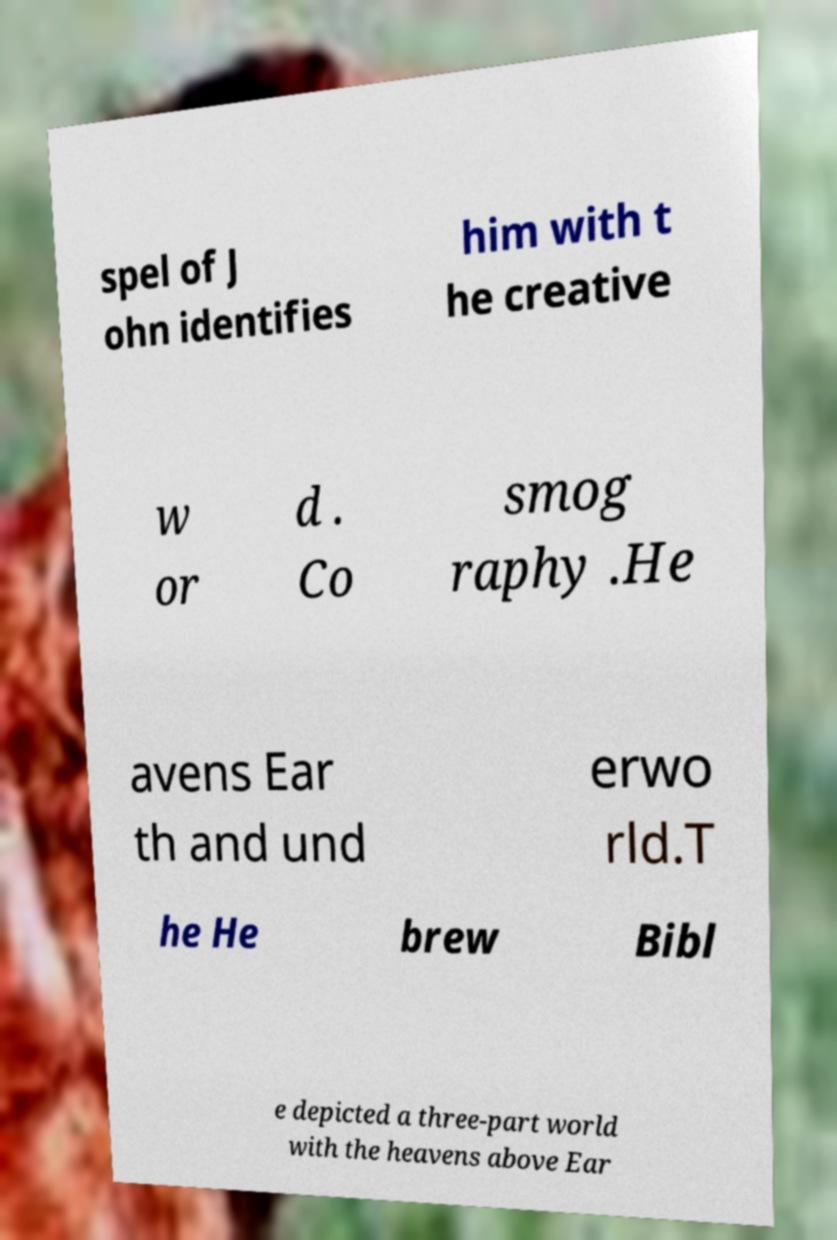Can you read and provide the text displayed in the image?This photo seems to have some interesting text. Can you extract and type it out for me? spel of J ohn identifies him with t he creative w or d . Co smog raphy .He avens Ear th and und erwo rld.T he He brew Bibl e depicted a three-part world with the heavens above Ear 